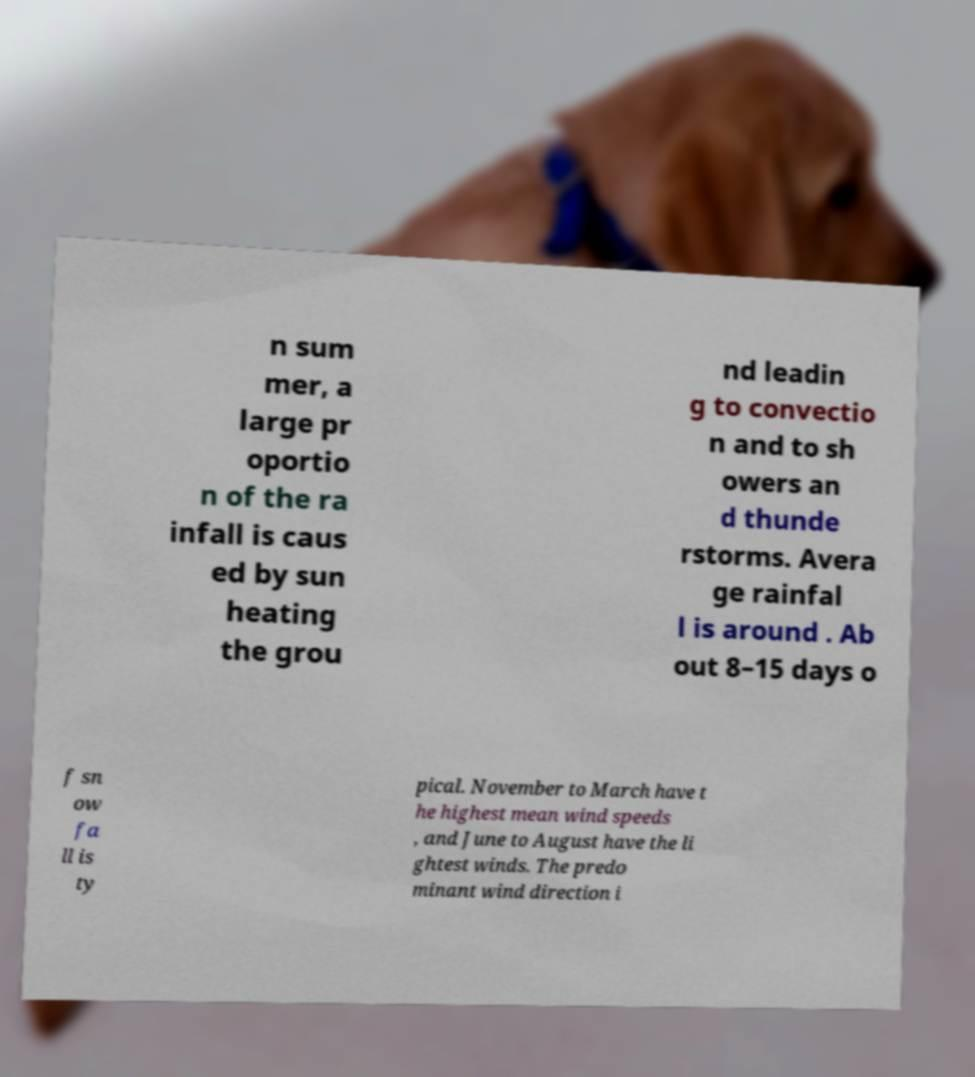There's text embedded in this image that I need extracted. Can you transcribe it verbatim? n sum mer, a large pr oportio n of the ra infall is caus ed by sun heating the grou nd leadin g to convectio n and to sh owers an d thunde rstorms. Avera ge rainfal l is around . Ab out 8–15 days o f sn ow fa ll is ty pical. November to March have t he highest mean wind speeds , and June to August have the li ghtest winds. The predo minant wind direction i 